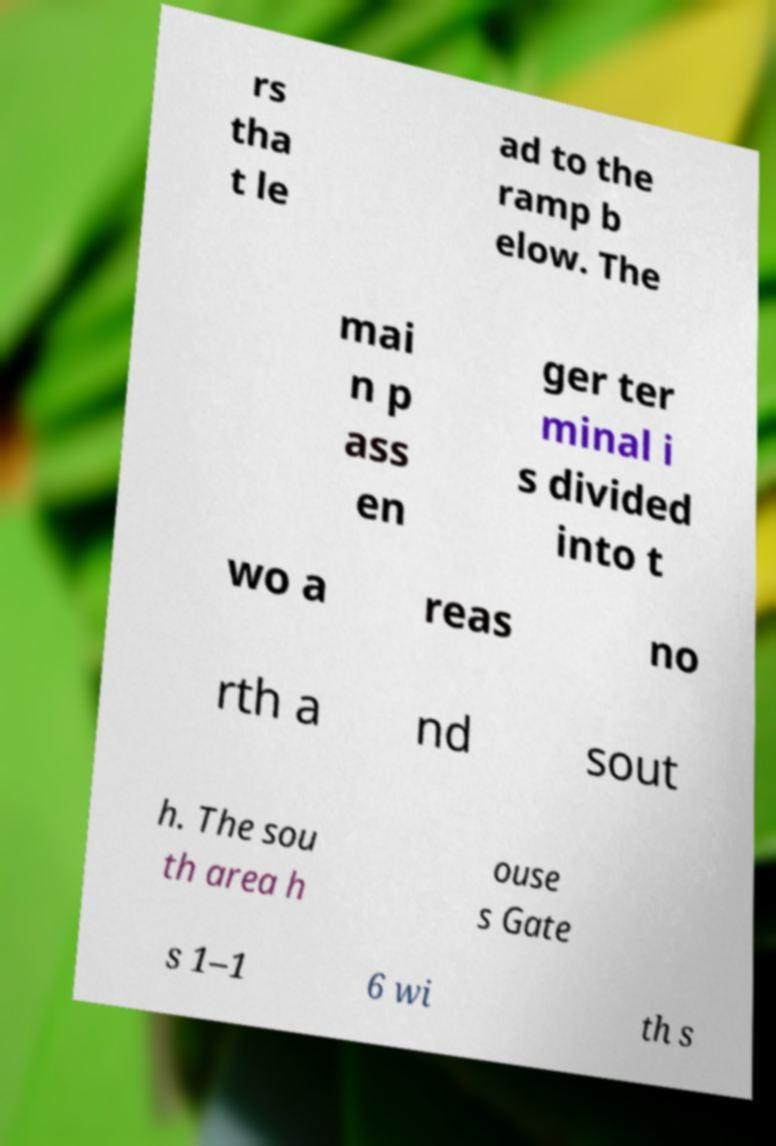What messages or text are displayed in this image? I need them in a readable, typed format. rs tha t le ad to the ramp b elow. The mai n p ass en ger ter minal i s divided into t wo a reas no rth a nd sout h. The sou th area h ouse s Gate s 1–1 6 wi th s 